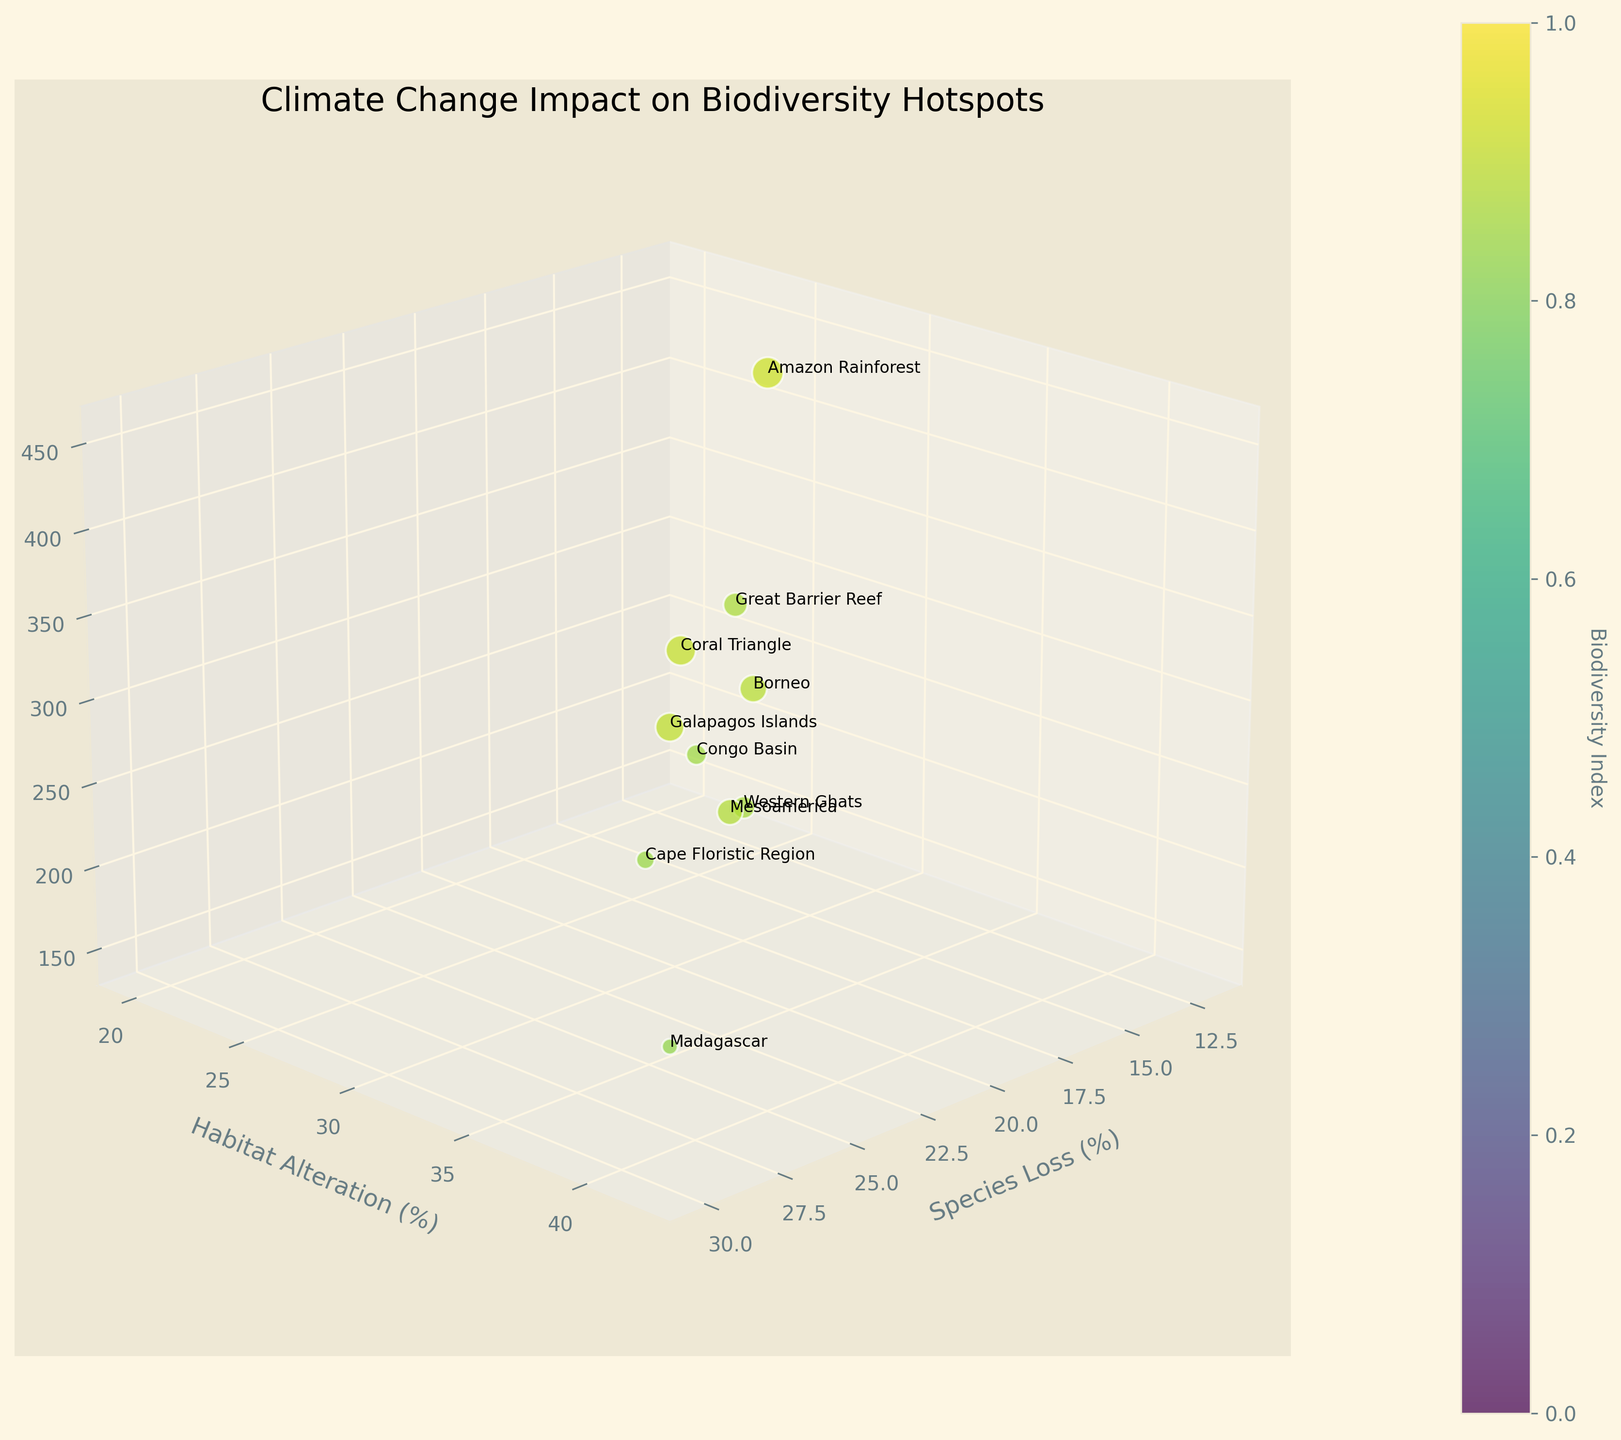What is the title of the figure? The title is located at the top of the chart and provides the main topic being visualized. It reads "Climate Change Impact on Biodiversity Hotspots".
Answer: Climate Change Impact on Biodiversity Hotspots What are the x, y, and z axes labeling? The labels for the axes are written next to each axis: x-axis is "Species Loss (%)", y-axis is "Habitat Alteration (%)", and z-axis is "Conservation Efforts (Million USD)".
Answer: Species Loss (%), Habitat Alteration (%), Conservation Efforts (Million USD) Which region experiences the highest percentage of habitat alteration? By comparing the y-axis values, Madagascar has the highest value at 42%.
Answer: Madagascar What is the relationship between species loss and habitat alteration for the Amazon Rainforest? Check the x-axis and y-axis values for the Amazon Rainforest, which are 15% and 28%, respectively.
Answer: Species loss is 15% and habitat alteration is 28% How many regions have a biodiversity index greater than 9.0? Count the number of regions where the color (indicating Biodiversity Index) corresponds to values greater than 9.0. These regions are Amazon Rainforest, Coral Triangle, and Galapagos Islands.
Answer: 3 Which region has the highest conservation efforts in Million USD? Look at the z-axis values to find the highest one, which is 450 Million USD for the Amazon Rainforest.
Answer: Amazon Rainforest Is there any region with a species loss percentage greater than 20% but less than 30%? Check the x-axis values to find regions within this range: Great Barrier Reef (22%), Borneo (18%), Congo Basin (25%), Western Ghats (20%), and Mesoamerica (23%).
Answer: Great Barrier Reef, Congo Basin, Mesoamerica What region has the lowest percentage of habitat alteration? Compare the y-axis values and find that the Galapagos Islands have the lowest value at 20%.
Answer: Galapagos Islands How does the conservation effort for the Great Barrier Reef compare to the Cape Floristic Region? The z-axis values show that the Great Barrier Reef has 380 Million USD while the Cape Floristic Region has 150 Million USD in conservation efforts.
Answer: Greater for the Great Barrier Reef Which regions show a conservation effort between 300 and 400 Million USD? Find the z-axis values within this range: Great Barrier Reef (380), Congo Basin (320).
Answer: Great Barrier Reef, Congo Basin 